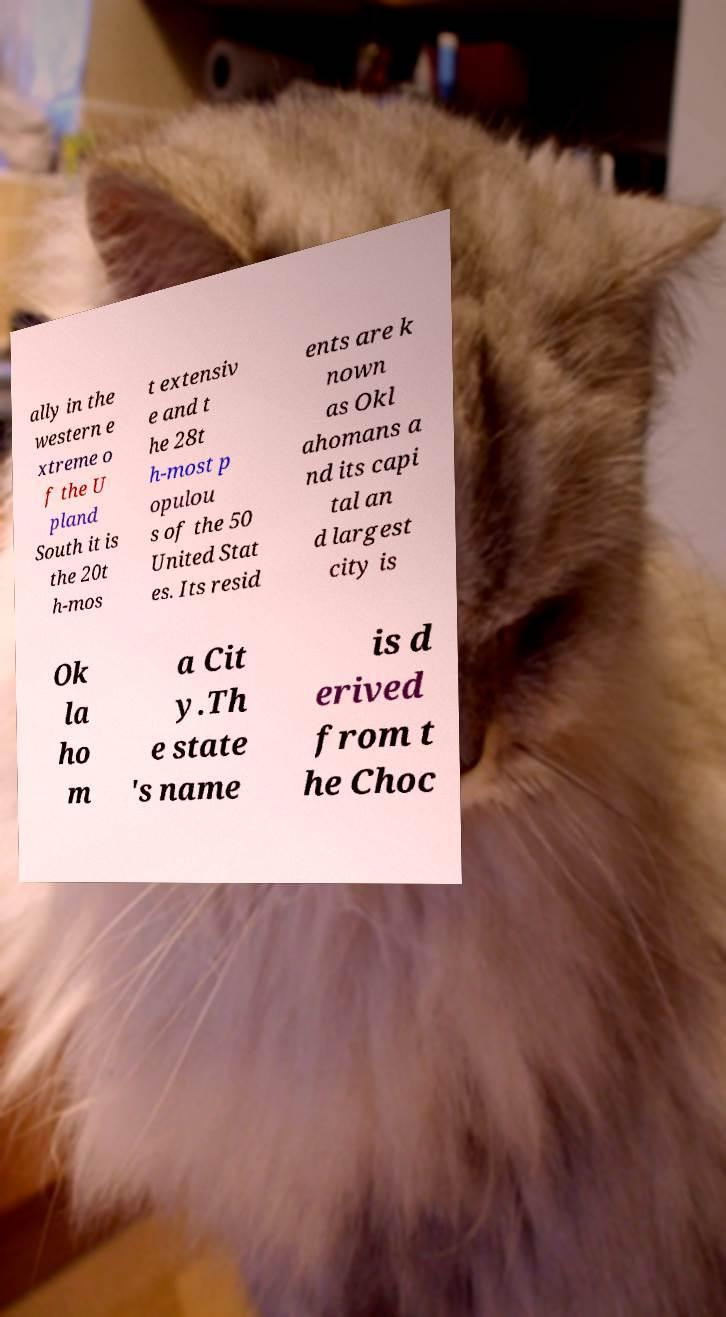Please identify and transcribe the text found in this image. ally in the western e xtreme o f the U pland South it is the 20t h-mos t extensiv e and t he 28t h-most p opulou s of the 50 United Stat es. Its resid ents are k nown as Okl ahomans a nd its capi tal an d largest city is Ok la ho m a Cit y.Th e state 's name is d erived from t he Choc 